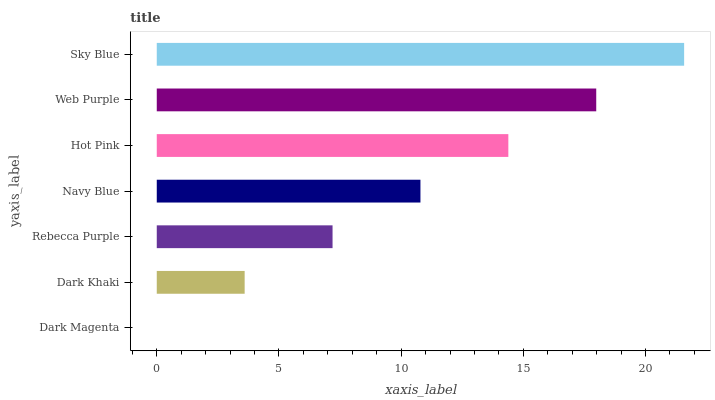Is Dark Magenta the minimum?
Answer yes or no. Yes. Is Sky Blue the maximum?
Answer yes or no. Yes. Is Dark Khaki the minimum?
Answer yes or no. No. Is Dark Khaki the maximum?
Answer yes or no. No. Is Dark Khaki greater than Dark Magenta?
Answer yes or no. Yes. Is Dark Magenta less than Dark Khaki?
Answer yes or no. Yes. Is Dark Magenta greater than Dark Khaki?
Answer yes or no. No. Is Dark Khaki less than Dark Magenta?
Answer yes or no. No. Is Navy Blue the high median?
Answer yes or no. Yes. Is Navy Blue the low median?
Answer yes or no. Yes. Is Dark Khaki the high median?
Answer yes or no. No. Is Rebecca Purple the low median?
Answer yes or no. No. 